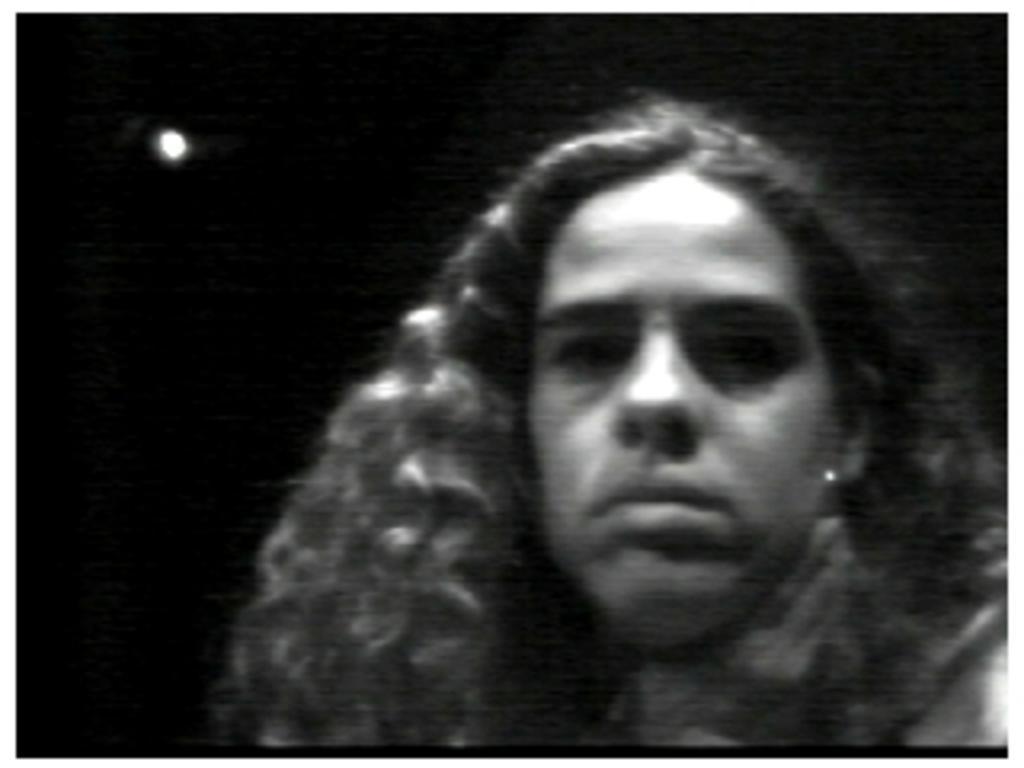How would you summarize this image in a sentence or two? In this image, I can see a woman and the background is dark in color. This picture might be taken during night. 